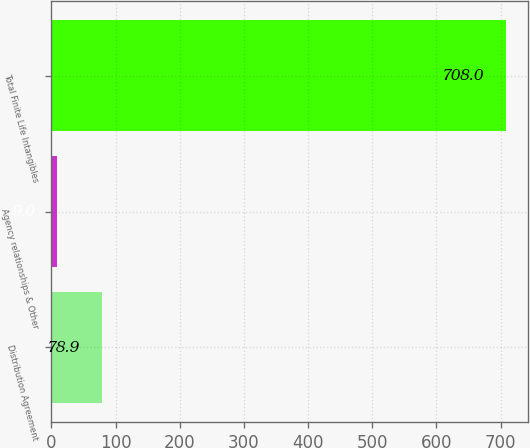<chart> <loc_0><loc_0><loc_500><loc_500><bar_chart><fcel>Distribution Agreement<fcel>Agency relationships & Other<fcel>Total Finite Life Intangibles<nl><fcel>78.9<fcel>9<fcel>708<nl></chart> 